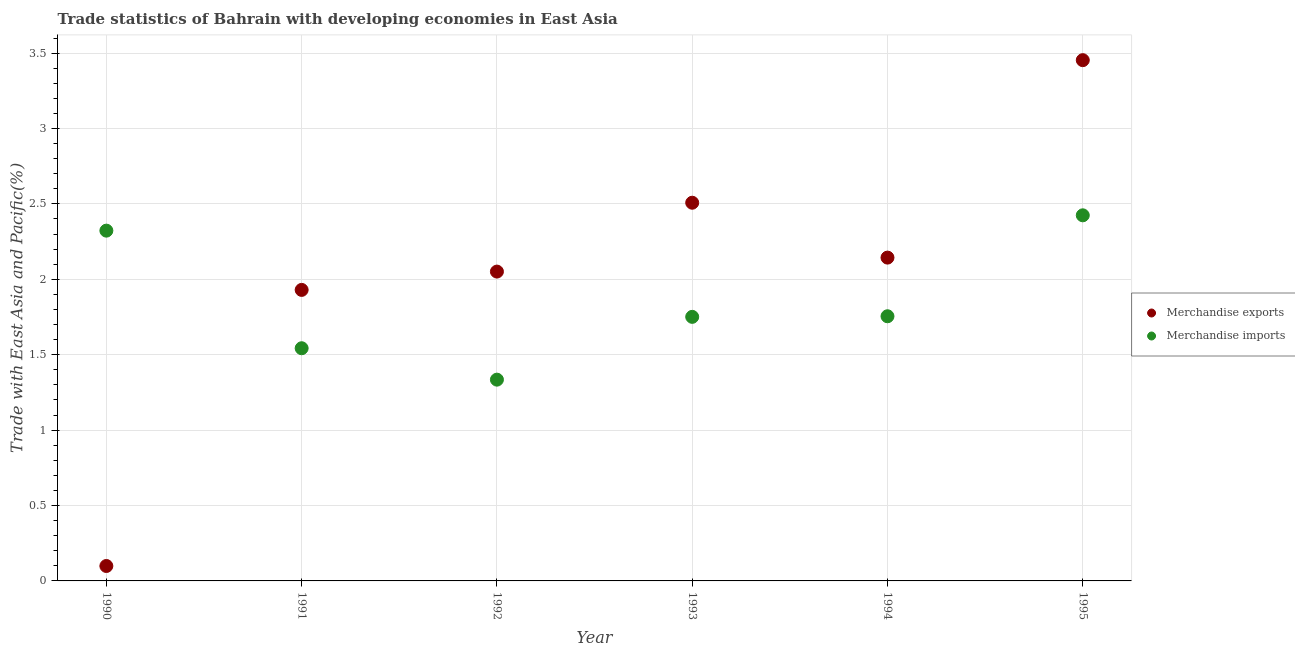What is the merchandise imports in 1990?
Make the answer very short. 2.32. Across all years, what is the maximum merchandise exports?
Your answer should be very brief. 3.45. Across all years, what is the minimum merchandise imports?
Give a very brief answer. 1.33. In which year was the merchandise imports maximum?
Give a very brief answer. 1995. What is the total merchandise imports in the graph?
Keep it short and to the point. 11.13. What is the difference between the merchandise exports in 1994 and that in 1995?
Provide a succinct answer. -1.31. What is the difference between the merchandise imports in 1994 and the merchandise exports in 1991?
Your answer should be very brief. -0.17. What is the average merchandise exports per year?
Ensure brevity in your answer.  2.03. In the year 1990, what is the difference between the merchandise imports and merchandise exports?
Your answer should be very brief. 2.22. In how many years, is the merchandise exports greater than 1.1 %?
Your response must be concise. 5. What is the ratio of the merchandise exports in 1991 to that in 1993?
Offer a very short reply. 0.77. Is the difference between the merchandise imports in 1990 and 1993 greater than the difference between the merchandise exports in 1990 and 1993?
Offer a very short reply. Yes. What is the difference between the highest and the second highest merchandise exports?
Provide a short and direct response. 0.95. What is the difference between the highest and the lowest merchandise exports?
Offer a terse response. 3.35. Does the merchandise exports monotonically increase over the years?
Give a very brief answer. No. Is the merchandise imports strictly less than the merchandise exports over the years?
Offer a terse response. No. How many years are there in the graph?
Make the answer very short. 6. Does the graph contain any zero values?
Keep it short and to the point. No. What is the title of the graph?
Your answer should be very brief. Trade statistics of Bahrain with developing economies in East Asia. Does "Number of departures" appear as one of the legend labels in the graph?
Your answer should be compact. No. What is the label or title of the Y-axis?
Give a very brief answer. Trade with East Asia and Pacific(%). What is the Trade with East Asia and Pacific(%) of Merchandise exports in 1990?
Ensure brevity in your answer.  0.1. What is the Trade with East Asia and Pacific(%) in Merchandise imports in 1990?
Provide a short and direct response. 2.32. What is the Trade with East Asia and Pacific(%) in Merchandise exports in 1991?
Offer a terse response. 1.93. What is the Trade with East Asia and Pacific(%) of Merchandise imports in 1991?
Provide a short and direct response. 1.54. What is the Trade with East Asia and Pacific(%) in Merchandise exports in 1992?
Your answer should be very brief. 2.05. What is the Trade with East Asia and Pacific(%) of Merchandise imports in 1992?
Offer a terse response. 1.33. What is the Trade with East Asia and Pacific(%) in Merchandise exports in 1993?
Offer a very short reply. 2.51. What is the Trade with East Asia and Pacific(%) in Merchandise imports in 1993?
Your answer should be compact. 1.75. What is the Trade with East Asia and Pacific(%) of Merchandise exports in 1994?
Provide a short and direct response. 2.14. What is the Trade with East Asia and Pacific(%) of Merchandise imports in 1994?
Your answer should be compact. 1.76. What is the Trade with East Asia and Pacific(%) of Merchandise exports in 1995?
Your response must be concise. 3.45. What is the Trade with East Asia and Pacific(%) in Merchandise imports in 1995?
Give a very brief answer. 2.42. Across all years, what is the maximum Trade with East Asia and Pacific(%) of Merchandise exports?
Provide a succinct answer. 3.45. Across all years, what is the maximum Trade with East Asia and Pacific(%) of Merchandise imports?
Make the answer very short. 2.42. Across all years, what is the minimum Trade with East Asia and Pacific(%) in Merchandise exports?
Provide a succinct answer. 0.1. Across all years, what is the minimum Trade with East Asia and Pacific(%) of Merchandise imports?
Your answer should be very brief. 1.33. What is the total Trade with East Asia and Pacific(%) of Merchandise exports in the graph?
Provide a succinct answer. 12.18. What is the total Trade with East Asia and Pacific(%) of Merchandise imports in the graph?
Provide a succinct answer. 11.13. What is the difference between the Trade with East Asia and Pacific(%) in Merchandise exports in 1990 and that in 1991?
Keep it short and to the point. -1.83. What is the difference between the Trade with East Asia and Pacific(%) of Merchandise imports in 1990 and that in 1991?
Offer a terse response. 0.78. What is the difference between the Trade with East Asia and Pacific(%) in Merchandise exports in 1990 and that in 1992?
Provide a succinct answer. -1.95. What is the difference between the Trade with East Asia and Pacific(%) of Merchandise imports in 1990 and that in 1992?
Ensure brevity in your answer.  0.99. What is the difference between the Trade with East Asia and Pacific(%) of Merchandise exports in 1990 and that in 1993?
Your response must be concise. -2.41. What is the difference between the Trade with East Asia and Pacific(%) in Merchandise imports in 1990 and that in 1993?
Provide a short and direct response. 0.57. What is the difference between the Trade with East Asia and Pacific(%) of Merchandise exports in 1990 and that in 1994?
Provide a short and direct response. -2.04. What is the difference between the Trade with East Asia and Pacific(%) in Merchandise imports in 1990 and that in 1994?
Your answer should be compact. 0.57. What is the difference between the Trade with East Asia and Pacific(%) in Merchandise exports in 1990 and that in 1995?
Keep it short and to the point. -3.35. What is the difference between the Trade with East Asia and Pacific(%) in Merchandise imports in 1990 and that in 1995?
Ensure brevity in your answer.  -0.1. What is the difference between the Trade with East Asia and Pacific(%) in Merchandise exports in 1991 and that in 1992?
Your response must be concise. -0.12. What is the difference between the Trade with East Asia and Pacific(%) in Merchandise imports in 1991 and that in 1992?
Ensure brevity in your answer.  0.21. What is the difference between the Trade with East Asia and Pacific(%) of Merchandise exports in 1991 and that in 1993?
Offer a very short reply. -0.58. What is the difference between the Trade with East Asia and Pacific(%) in Merchandise imports in 1991 and that in 1993?
Provide a short and direct response. -0.21. What is the difference between the Trade with East Asia and Pacific(%) of Merchandise exports in 1991 and that in 1994?
Make the answer very short. -0.21. What is the difference between the Trade with East Asia and Pacific(%) of Merchandise imports in 1991 and that in 1994?
Provide a short and direct response. -0.21. What is the difference between the Trade with East Asia and Pacific(%) of Merchandise exports in 1991 and that in 1995?
Give a very brief answer. -1.52. What is the difference between the Trade with East Asia and Pacific(%) of Merchandise imports in 1991 and that in 1995?
Provide a succinct answer. -0.88. What is the difference between the Trade with East Asia and Pacific(%) in Merchandise exports in 1992 and that in 1993?
Make the answer very short. -0.46. What is the difference between the Trade with East Asia and Pacific(%) of Merchandise imports in 1992 and that in 1993?
Your answer should be compact. -0.42. What is the difference between the Trade with East Asia and Pacific(%) of Merchandise exports in 1992 and that in 1994?
Your answer should be compact. -0.09. What is the difference between the Trade with East Asia and Pacific(%) of Merchandise imports in 1992 and that in 1994?
Your answer should be very brief. -0.42. What is the difference between the Trade with East Asia and Pacific(%) of Merchandise exports in 1992 and that in 1995?
Your response must be concise. -1.4. What is the difference between the Trade with East Asia and Pacific(%) of Merchandise imports in 1992 and that in 1995?
Your answer should be very brief. -1.09. What is the difference between the Trade with East Asia and Pacific(%) of Merchandise exports in 1993 and that in 1994?
Offer a terse response. 0.36. What is the difference between the Trade with East Asia and Pacific(%) in Merchandise imports in 1993 and that in 1994?
Your answer should be compact. -0. What is the difference between the Trade with East Asia and Pacific(%) of Merchandise exports in 1993 and that in 1995?
Make the answer very short. -0.95. What is the difference between the Trade with East Asia and Pacific(%) in Merchandise imports in 1993 and that in 1995?
Keep it short and to the point. -0.67. What is the difference between the Trade with East Asia and Pacific(%) in Merchandise exports in 1994 and that in 1995?
Your answer should be very brief. -1.31. What is the difference between the Trade with East Asia and Pacific(%) of Merchandise imports in 1994 and that in 1995?
Offer a terse response. -0.67. What is the difference between the Trade with East Asia and Pacific(%) in Merchandise exports in 1990 and the Trade with East Asia and Pacific(%) in Merchandise imports in 1991?
Provide a succinct answer. -1.44. What is the difference between the Trade with East Asia and Pacific(%) in Merchandise exports in 1990 and the Trade with East Asia and Pacific(%) in Merchandise imports in 1992?
Offer a very short reply. -1.24. What is the difference between the Trade with East Asia and Pacific(%) of Merchandise exports in 1990 and the Trade with East Asia and Pacific(%) of Merchandise imports in 1993?
Offer a terse response. -1.65. What is the difference between the Trade with East Asia and Pacific(%) in Merchandise exports in 1990 and the Trade with East Asia and Pacific(%) in Merchandise imports in 1994?
Make the answer very short. -1.66. What is the difference between the Trade with East Asia and Pacific(%) in Merchandise exports in 1990 and the Trade with East Asia and Pacific(%) in Merchandise imports in 1995?
Offer a very short reply. -2.33. What is the difference between the Trade with East Asia and Pacific(%) of Merchandise exports in 1991 and the Trade with East Asia and Pacific(%) of Merchandise imports in 1992?
Provide a short and direct response. 0.6. What is the difference between the Trade with East Asia and Pacific(%) of Merchandise exports in 1991 and the Trade with East Asia and Pacific(%) of Merchandise imports in 1993?
Offer a terse response. 0.18. What is the difference between the Trade with East Asia and Pacific(%) in Merchandise exports in 1991 and the Trade with East Asia and Pacific(%) in Merchandise imports in 1994?
Make the answer very short. 0.17. What is the difference between the Trade with East Asia and Pacific(%) of Merchandise exports in 1991 and the Trade with East Asia and Pacific(%) of Merchandise imports in 1995?
Keep it short and to the point. -0.49. What is the difference between the Trade with East Asia and Pacific(%) of Merchandise exports in 1992 and the Trade with East Asia and Pacific(%) of Merchandise imports in 1993?
Offer a very short reply. 0.3. What is the difference between the Trade with East Asia and Pacific(%) in Merchandise exports in 1992 and the Trade with East Asia and Pacific(%) in Merchandise imports in 1994?
Make the answer very short. 0.3. What is the difference between the Trade with East Asia and Pacific(%) of Merchandise exports in 1992 and the Trade with East Asia and Pacific(%) of Merchandise imports in 1995?
Provide a succinct answer. -0.37. What is the difference between the Trade with East Asia and Pacific(%) of Merchandise exports in 1993 and the Trade with East Asia and Pacific(%) of Merchandise imports in 1994?
Provide a succinct answer. 0.75. What is the difference between the Trade with East Asia and Pacific(%) in Merchandise exports in 1993 and the Trade with East Asia and Pacific(%) in Merchandise imports in 1995?
Offer a very short reply. 0.08. What is the difference between the Trade with East Asia and Pacific(%) in Merchandise exports in 1994 and the Trade with East Asia and Pacific(%) in Merchandise imports in 1995?
Ensure brevity in your answer.  -0.28. What is the average Trade with East Asia and Pacific(%) in Merchandise exports per year?
Ensure brevity in your answer.  2.03. What is the average Trade with East Asia and Pacific(%) of Merchandise imports per year?
Give a very brief answer. 1.86. In the year 1990, what is the difference between the Trade with East Asia and Pacific(%) of Merchandise exports and Trade with East Asia and Pacific(%) of Merchandise imports?
Keep it short and to the point. -2.22. In the year 1991, what is the difference between the Trade with East Asia and Pacific(%) of Merchandise exports and Trade with East Asia and Pacific(%) of Merchandise imports?
Your answer should be compact. 0.39. In the year 1992, what is the difference between the Trade with East Asia and Pacific(%) in Merchandise exports and Trade with East Asia and Pacific(%) in Merchandise imports?
Provide a succinct answer. 0.72. In the year 1993, what is the difference between the Trade with East Asia and Pacific(%) in Merchandise exports and Trade with East Asia and Pacific(%) in Merchandise imports?
Offer a very short reply. 0.76. In the year 1994, what is the difference between the Trade with East Asia and Pacific(%) of Merchandise exports and Trade with East Asia and Pacific(%) of Merchandise imports?
Offer a terse response. 0.39. In the year 1995, what is the difference between the Trade with East Asia and Pacific(%) of Merchandise exports and Trade with East Asia and Pacific(%) of Merchandise imports?
Your answer should be compact. 1.03. What is the ratio of the Trade with East Asia and Pacific(%) of Merchandise exports in 1990 to that in 1991?
Your answer should be very brief. 0.05. What is the ratio of the Trade with East Asia and Pacific(%) of Merchandise imports in 1990 to that in 1991?
Give a very brief answer. 1.51. What is the ratio of the Trade with East Asia and Pacific(%) of Merchandise exports in 1990 to that in 1992?
Your answer should be very brief. 0.05. What is the ratio of the Trade with East Asia and Pacific(%) of Merchandise imports in 1990 to that in 1992?
Offer a very short reply. 1.74. What is the ratio of the Trade with East Asia and Pacific(%) in Merchandise exports in 1990 to that in 1993?
Give a very brief answer. 0.04. What is the ratio of the Trade with East Asia and Pacific(%) in Merchandise imports in 1990 to that in 1993?
Offer a terse response. 1.33. What is the ratio of the Trade with East Asia and Pacific(%) in Merchandise exports in 1990 to that in 1994?
Your answer should be very brief. 0.05. What is the ratio of the Trade with East Asia and Pacific(%) of Merchandise imports in 1990 to that in 1994?
Your answer should be compact. 1.32. What is the ratio of the Trade with East Asia and Pacific(%) of Merchandise exports in 1990 to that in 1995?
Give a very brief answer. 0.03. What is the ratio of the Trade with East Asia and Pacific(%) in Merchandise imports in 1990 to that in 1995?
Your answer should be very brief. 0.96. What is the ratio of the Trade with East Asia and Pacific(%) in Merchandise exports in 1991 to that in 1992?
Offer a terse response. 0.94. What is the ratio of the Trade with East Asia and Pacific(%) in Merchandise imports in 1991 to that in 1992?
Offer a very short reply. 1.16. What is the ratio of the Trade with East Asia and Pacific(%) in Merchandise exports in 1991 to that in 1993?
Give a very brief answer. 0.77. What is the ratio of the Trade with East Asia and Pacific(%) of Merchandise imports in 1991 to that in 1993?
Your answer should be compact. 0.88. What is the ratio of the Trade with East Asia and Pacific(%) in Merchandise exports in 1991 to that in 1994?
Make the answer very short. 0.9. What is the ratio of the Trade with East Asia and Pacific(%) in Merchandise imports in 1991 to that in 1994?
Make the answer very short. 0.88. What is the ratio of the Trade with East Asia and Pacific(%) in Merchandise exports in 1991 to that in 1995?
Ensure brevity in your answer.  0.56. What is the ratio of the Trade with East Asia and Pacific(%) of Merchandise imports in 1991 to that in 1995?
Provide a succinct answer. 0.64. What is the ratio of the Trade with East Asia and Pacific(%) of Merchandise exports in 1992 to that in 1993?
Your answer should be compact. 0.82. What is the ratio of the Trade with East Asia and Pacific(%) of Merchandise imports in 1992 to that in 1993?
Provide a short and direct response. 0.76. What is the ratio of the Trade with East Asia and Pacific(%) in Merchandise exports in 1992 to that in 1994?
Your answer should be compact. 0.96. What is the ratio of the Trade with East Asia and Pacific(%) in Merchandise imports in 1992 to that in 1994?
Your answer should be very brief. 0.76. What is the ratio of the Trade with East Asia and Pacific(%) of Merchandise exports in 1992 to that in 1995?
Offer a very short reply. 0.59. What is the ratio of the Trade with East Asia and Pacific(%) in Merchandise imports in 1992 to that in 1995?
Offer a terse response. 0.55. What is the ratio of the Trade with East Asia and Pacific(%) in Merchandise exports in 1993 to that in 1994?
Offer a very short reply. 1.17. What is the ratio of the Trade with East Asia and Pacific(%) in Merchandise imports in 1993 to that in 1994?
Make the answer very short. 1. What is the ratio of the Trade with East Asia and Pacific(%) of Merchandise exports in 1993 to that in 1995?
Provide a short and direct response. 0.73. What is the ratio of the Trade with East Asia and Pacific(%) of Merchandise imports in 1993 to that in 1995?
Offer a terse response. 0.72. What is the ratio of the Trade with East Asia and Pacific(%) of Merchandise exports in 1994 to that in 1995?
Provide a short and direct response. 0.62. What is the ratio of the Trade with East Asia and Pacific(%) of Merchandise imports in 1994 to that in 1995?
Offer a very short reply. 0.72. What is the difference between the highest and the second highest Trade with East Asia and Pacific(%) of Merchandise exports?
Provide a succinct answer. 0.95. What is the difference between the highest and the second highest Trade with East Asia and Pacific(%) of Merchandise imports?
Offer a terse response. 0.1. What is the difference between the highest and the lowest Trade with East Asia and Pacific(%) in Merchandise exports?
Make the answer very short. 3.35. What is the difference between the highest and the lowest Trade with East Asia and Pacific(%) of Merchandise imports?
Offer a very short reply. 1.09. 